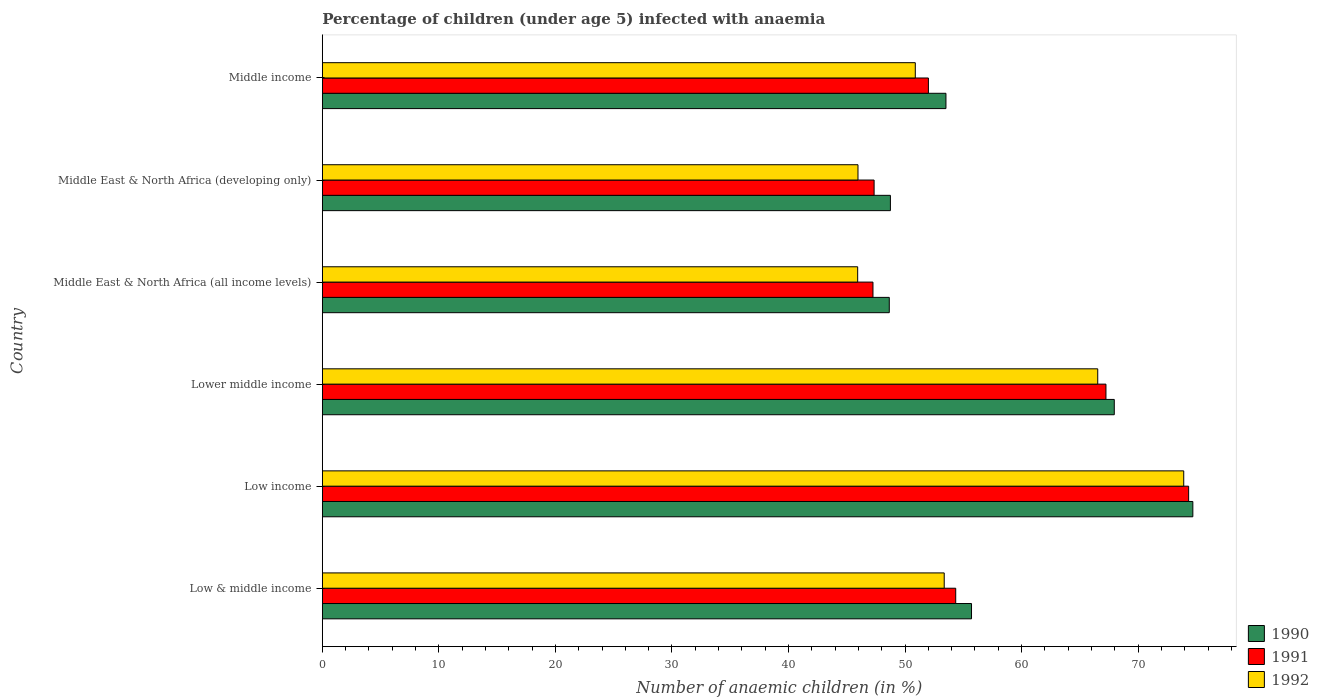Are the number of bars per tick equal to the number of legend labels?
Keep it short and to the point. Yes. Are the number of bars on each tick of the Y-axis equal?
Offer a terse response. Yes. How many bars are there on the 1st tick from the top?
Your response must be concise. 3. What is the label of the 5th group of bars from the top?
Your answer should be compact. Low income. What is the percentage of children infected with anaemia in in 1990 in Low & middle income?
Your answer should be very brief. 55.7. Across all countries, what is the maximum percentage of children infected with anaemia in in 1990?
Keep it short and to the point. 74.69. Across all countries, what is the minimum percentage of children infected with anaemia in in 1991?
Your answer should be compact. 47.25. In which country was the percentage of children infected with anaemia in in 1991 maximum?
Provide a succinct answer. Low income. In which country was the percentage of children infected with anaemia in in 1992 minimum?
Your answer should be very brief. Middle East & North Africa (all income levels). What is the total percentage of children infected with anaemia in in 1990 in the graph?
Offer a very short reply. 349.25. What is the difference between the percentage of children infected with anaemia in in 1991 in Low income and that in Lower middle income?
Provide a succinct answer. 7.1. What is the difference between the percentage of children infected with anaemia in in 1991 in Lower middle income and the percentage of children infected with anaemia in in 1992 in Low income?
Provide a short and direct response. -6.67. What is the average percentage of children infected with anaemia in in 1992 per country?
Provide a succinct answer. 56.1. What is the difference between the percentage of children infected with anaemia in in 1990 and percentage of children infected with anaemia in in 1991 in Low income?
Your response must be concise. 0.36. What is the ratio of the percentage of children infected with anaemia in in 1990 in Low & middle income to that in Low income?
Your answer should be compact. 0.75. Is the difference between the percentage of children infected with anaemia in in 1990 in Lower middle income and Middle East & North Africa (all income levels) greater than the difference between the percentage of children infected with anaemia in in 1991 in Lower middle income and Middle East & North Africa (all income levels)?
Your response must be concise. No. What is the difference between the highest and the second highest percentage of children infected with anaemia in in 1990?
Make the answer very short. 6.74. What is the difference between the highest and the lowest percentage of children infected with anaemia in in 1990?
Make the answer very short. 26.05. How many bars are there?
Give a very brief answer. 18. What is the difference between two consecutive major ticks on the X-axis?
Offer a terse response. 10. Does the graph contain grids?
Keep it short and to the point. No. Where does the legend appear in the graph?
Ensure brevity in your answer.  Bottom right. How many legend labels are there?
Offer a very short reply. 3. How are the legend labels stacked?
Your answer should be very brief. Vertical. What is the title of the graph?
Ensure brevity in your answer.  Percentage of children (under age 5) infected with anaemia. Does "1973" appear as one of the legend labels in the graph?
Make the answer very short. No. What is the label or title of the X-axis?
Your answer should be very brief. Number of anaemic children (in %). What is the Number of anaemic children (in %) of 1990 in Low & middle income?
Offer a very short reply. 55.7. What is the Number of anaemic children (in %) in 1991 in Low & middle income?
Your answer should be very brief. 54.35. What is the Number of anaemic children (in %) in 1992 in Low & middle income?
Make the answer very short. 53.36. What is the Number of anaemic children (in %) of 1990 in Low income?
Your answer should be compact. 74.69. What is the Number of anaemic children (in %) of 1991 in Low income?
Ensure brevity in your answer.  74.33. What is the Number of anaemic children (in %) of 1992 in Low income?
Ensure brevity in your answer.  73.91. What is the Number of anaemic children (in %) of 1990 in Lower middle income?
Your response must be concise. 67.95. What is the Number of anaemic children (in %) in 1991 in Lower middle income?
Keep it short and to the point. 67.24. What is the Number of anaemic children (in %) in 1992 in Lower middle income?
Your answer should be very brief. 66.53. What is the Number of anaemic children (in %) in 1990 in Middle East & North Africa (all income levels)?
Provide a succinct answer. 48.65. What is the Number of anaemic children (in %) of 1991 in Middle East & North Africa (all income levels)?
Your answer should be compact. 47.25. What is the Number of anaemic children (in %) of 1992 in Middle East & North Africa (all income levels)?
Your response must be concise. 45.93. What is the Number of anaemic children (in %) in 1990 in Middle East & North Africa (developing only)?
Offer a terse response. 48.74. What is the Number of anaemic children (in %) in 1991 in Middle East & North Africa (developing only)?
Your answer should be very brief. 47.35. What is the Number of anaemic children (in %) of 1992 in Middle East & North Africa (developing only)?
Give a very brief answer. 45.96. What is the Number of anaemic children (in %) of 1990 in Middle income?
Keep it short and to the point. 53.51. What is the Number of anaemic children (in %) of 1991 in Middle income?
Give a very brief answer. 52. What is the Number of anaemic children (in %) in 1992 in Middle income?
Keep it short and to the point. 50.88. Across all countries, what is the maximum Number of anaemic children (in %) in 1990?
Your response must be concise. 74.69. Across all countries, what is the maximum Number of anaemic children (in %) in 1991?
Offer a terse response. 74.33. Across all countries, what is the maximum Number of anaemic children (in %) in 1992?
Provide a succinct answer. 73.91. Across all countries, what is the minimum Number of anaemic children (in %) of 1990?
Your response must be concise. 48.65. Across all countries, what is the minimum Number of anaemic children (in %) in 1991?
Give a very brief answer. 47.25. Across all countries, what is the minimum Number of anaemic children (in %) of 1992?
Your answer should be compact. 45.93. What is the total Number of anaemic children (in %) of 1990 in the graph?
Offer a very short reply. 349.25. What is the total Number of anaemic children (in %) of 1991 in the graph?
Offer a very short reply. 342.52. What is the total Number of anaemic children (in %) in 1992 in the graph?
Give a very brief answer. 336.58. What is the difference between the Number of anaemic children (in %) of 1990 in Low & middle income and that in Low income?
Offer a terse response. -18.99. What is the difference between the Number of anaemic children (in %) of 1991 in Low & middle income and that in Low income?
Your response must be concise. -19.99. What is the difference between the Number of anaemic children (in %) of 1992 in Low & middle income and that in Low income?
Give a very brief answer. -20.55. What is the difference between the Number of anaemic children (in %) of 1990 in Low & middle income and that in Lower middle income?
Ensure brevity in your answer.  -12.25. What is the difference between the Number of anaemic children (in %) in 1991 in Low & middle income and that in Lower middle income?
Give a very brief answer. -12.89. What is the difference between the Number of anaemic children (in %) in 1992 in Low & middle income and that in Lower middle income?
Ensure brevity in your answer.  -13.17. What is the difference between the Number of anaemic children (in %) in 1990 in Low & middle income and that in Middle East & North Africa (all income levels)?
Offer a very short reply. 7.06. What is the difference between the Number of anaemic children (in %) in 1991 in Low & middle income and that in Middle East & North Africa (all income levels)?
Make the answer very short. 7.1. What is the difference between the Number of anaemic children (in %) of 1992 in Low & middle income and that in Middle East & North Africa (all income levels)?
Your answer should be compact. 7.43. What is the difference between the Number of anaemic children (in %) in 1990 in Low & middle income and that in Middle East & North Africa (developing only)?
Provide a short and direct response. 6.96. What is the difference between the Number of anaemic children (in %) of 1991 in Low & middle income and that in Middle East & North Africa (developing only)?
Give a very brief answer. 7. What is the difference between the Number of anaemic children (in %) of 1992 in Low & middle income and that in Middle East & North Africa (developing only)?
Your answer should be very brief. 7.4. What is the difference between the Number of anaemic children (in %) in 1990 in Low & middle income and that in Middle income?
Your answer should be compact. 2.19. What is the difference between the Number of anaemic children (in %) of 1991 in Low & middle income and that in Middle income?
Your answer should be very brief. 2.34. What is the difference between the Number of anaemic children (in %) of 1992 in Low & middle income and that in Middle income?
Make the answer very short. 2.48. What is the difference between the Number of anaemic children (in %) in 1990 in Low income and that in Lower middle income?
Make the answer very short. 6.74. What is the difference between the Number of anaemic children (in %) in 1991 in Low income and that in Lower middle income?
Offer a very short reply. 7.1. What is the difference between the Number of anaemic children (in %) in 1992 in Low income and that in Lower middle income?
Your answer should be very brief. 7.38. What is the difference between the Number of anaemic children (in %) in 1990 in Low income and that in Middle East & North Africa (all income levels)?
Your response must be concise. 26.05. What is the difference between the Number of anaemic children (in %) in 1991 in Low income and that in Middle East & North Africa (all income levels)?
Your answer should be very brief. 27.09. What is the difference between the Number of anaemic children (in %) of 1992 in Low income and that in Middle East & North Africa (all income levels)?
Offer a terse response. 27.98. What is the difference between the Number of anaemic children (in %) of 1990 in Low income and that in Middle East & North Africa (developing only)?
Your response must be concise. 25.95. What is the difference between the Number of anaemic children (in %) of 1991 in Low income and that in Middle East & North Africa (developing only)?
Provide a succinct answer. 26.99. What is the difference between the Number of anaemic children (in %) in 1992 in Low income and that in Middle East & North Africa (developing only)?
Give a very brief answer. 27.95. What is the difference between the Number of anaemic children (in %) in 1990 in Low income and that in Middle income?
Offer a very short reply. 21.18. What is the difference between the Number of anaemic children (in %) in 1991 in Low income and that in Middle income?
Your answer should be compact. 22.33. What is the difference between the Number of anaemic children (in %) of 1992 in Low income and that in Middle income?
Offer a terse response. 23.03. What is the difference between the Number of anaemic children (in %) of 1990 in Lower middle income and that in Middle East & North Africa (all income levels)?
Make the answer very short. 19.31. What is the difference between the Number of anaemic children (in %) in 1991 in Lower middle income and that in Middle East & North Africa (all income levels)?
Offer a terse response. 19.99. What is the difference between the Number of anaemic children (in %) of 1992 in Lower middle income and that in Middle East & North Africa (all income levels)?
Offer a terse response. 20.6. What is the difference between the Number of anaemic children (in %) in 1990 in Lower middle income and that in Middle East & North Africa (developing only)?
Provide a short and direct response. 19.21. What is the difference between the Number of anaemic children (in %) of 1991 in Lower middle income and that in Middle East & North Africa (developing only)?
Ensure brevity in your answer.  19.89. What is the difference between the Number of anaemic children (in %) of 1992 in Lower middle income and that in Middle East & North Africa (developing only)?
Offer a terse response. 20.57. What is the difference between the Number of anaemic children (in %) in 1990 in Lower middle income and that in Middle income?
Offer a terse response. 14.44. What is the difference between the Number of anaemic children (in %) in 1991 in Lower middle income and that in Middle income?
Ensure brevity in your answer.  15.23. What is the difference between the Number of anaemic children (in %) in 1992 in Lower middle income and that in Middle income?
Make the answer very short. 15.65. What is the difference between the Number of anaemic children (in %) in 1990 in Middle East & North Africa (all income levels) and that in Middle East & North Africa (developing only)?
Offer a terse response. -0.1. What is the difference between the Number of anaemic children (in %) of 1991 in Middle East & North Africa (all income levels) and that in Middle East & North Africa (developing only)?
Offer a terse response. -0.1. What is the difference between the Number of anaemic children (in %) in 1992 in Middle East & North Africa (all income levels) and that in Middle East & North Africa (developing only)?
Provide a succinct answer. -0.03. What is the difference between the Number of anaemic children (in %) of 1990 in Middle East & North Africa (all income levels) and that in Middle income?
Give a very brief answer. -4.86. What is the difference between the Number of anaemic children (in %) of 1991 in Middle East & North Africa (all income levels) and that in Middle income?
Provide a short and direct response. -4.76. What is the difference between the Number of anaemic children (in %) of 1992 in Middle East & North Africa (all income levels) and that in Middle income?
Keep it short and to the point. -4.94. What is the difference between the Number of anaemic children (in %) of 1990 in Middle East & North Africa (developing only) and that in Middle income?
Offer a very short reply. -4.77. What is the difference between the Number of anaemic children (in %) of 1991 in Middle East & North Africa (developing only) and that in Middle income?
Provide a succinct answer. -4.66. What is the difference between the Number of anaemic children (in %) of 1992 in Middle East & North Africa (developing only) and that in Middle income?
Keep it short and to the point. -4.92. What is the difference between the Number of anaemic children (in %) of 1990 in Low & middle income and the Number of anaemic children (in %) of 1991 in Low income?
Your answer should be compact. -18.63. What is the difference between the Number of anaemic children (in %) in 1990 in Low & middle income and the Number of anaemic children (in %) in 1992 in Low income?
Keep it short and to the point. -18.21. What is the difference between the Number of anaemic children (in %) of 1991 in Low & middle income and the Number of anaemic children (in %) of 1992 in Low income?
Offer a terse response. -19.56. What is the difference between the Number of anaemic children (in %) in 1990 in Low & middle income and the Number of anaemic children (in %) in 1991 in Lower middle income?
Your answer should be very brief. -11.54. What is the difference between the Number of anaemic children (in %) in 1990 in Low & middle income and the Number of anaemic children (in %) in 1992 in Lower middle income?
Provide a succinct answer. -10.83. What is the difference between the Number of anaemic children (in %) of 1991 in Low & middle income and the Number of anaemic children (in %) of 1992 in Lower middle income?
Provide a succinct answer. -12.19. What is the difference between the Number of anaemic children (in %) of 1990 in Low & middle income and the Number of anaemic children (in %) of 1991 in Middle East & North Africa (all income levels)?
Ensure brevity in your answer.  8.46. What is the difference between the Number of anaemic children (in %) in 1990 in Low & middle income and the Number of anaemic children (in %) in 1992 in Middle East & North Africa (all income levels)?
Your answer should be compact. 9.77. What is the difference between the Number of anaemic children (in %) in 1991 in Low & middle income and the Number of anaemic children (in %) in 1992 in Middle East & North Africa (all income levels)?
Keep it short and to the point. 8.41. What is the difference between the Number of anaemic children (in %) in 1990 in Low & middle income and the Number of anaemic children (in %) in 1991 in Middle East & North Africa (developing only)?
Offer a very short reply. 8.36. What is the difference between the Number of anaemic children (in %) in 1990 in Low & middle income and the Number of anaemic children (in %) in 1992 in Middle East & North Africa (developing only)?
Provide a succinct answer. 9.74. What is the difference between the Number of anaemic children (in %) of 1991 in Low & middle income and the Number of anaemic children (in %) of 1992 in Middle East & North Africa (developing only)?
Offer a very short reply. 8.39. What is the difference between the Number of anaemic children (in %) in 1990 in Low & middle income and the Number of anaemic children (in %) in 1991 in Middle income?
Make the answer very short. 3.7. What is the difference between the Number of anaemic children (in %) of 1990 in Low & middle income and the Number of anaemic children (in %) of 1992 in Middle income?
Offer a terse response. 4.82. What is the difference between the Number of anaemic children (in %) in 1991 in Low & middle income and the Number of anaemic children (in %) in 1992 in Middle income?
Offer a very short reply. 3.47. What is the difference between the Number of anaemic children (in %) in 1990 in Low income and the Number of anaemic children (in %) in 1991 in Lower middle income?
Give a very brief answer. 7.46. What is the difference between the Number of anaemic children (in %) in 1990 in Low income and the Number of anaemic children (in %) in 1992 in Lower middle income?
Your response must be concise. 8.16. What is the difference between the Number of anaemic children (in %) of 1991 in Low income and the Number of anaemic children (in %) of 1992 in Lower middle income?
Make the answer very short. 7.8. What is the difference between the Number of anaemic children (in %) of 1990 in Low income and the Number of anaemic children (in %) of 1991 in Middle East & North Africa (all income levels)?
Ensure brevity in your answer.  27.45. What is the difference between the Number of anaemic children (in %) in 1990 in Low income and the Number of anaemic children (in %) in 1992 in Middle East & North Africa (all income levels)?
Provide a succinct answer. 28.76. What is the difference between the Number of anaemic children (in %) of 1991 in Low income and the Number of anaemic children (in %) of 1992 in Middle East & North Africa (all income levels)?
Offer a terse response. 28.4. What is the difference between the Number of anaemic children (in %) of 1990 in Low income and the Number of anaemic children (in %) of 1991 in Middle East & North Africa (developing only)?
Keep it short and to the point. 27.35. What is the difference between the Number of anaemic children (in %) of 1990 in Low income and the Number of anaemic children (in %) of 1992 in Middle East & North Africa (developing only)?
Your answer should be compact. 28.73. What is the difference between the Number of anaemic children (in %) in 1991 in Low income and the Number of anaemic children (in %) in 1992 in Middle East & North Africa (developing only)?
Provide a short and direct response. 28.37. What is the difference between the Number of anaemic children (in %) of 1990 in Low income and the Number of anaemic children (in %) of 1991 in Middle income?
Your answer should be compact. 22.69. What is the difference between the Number of anaemic children (in %) in 1990 in Low income and the Number of anaemic children (in %) in 1992 in Middle income?
Provide a short and direct response. 23.81. What is the difference between the Number of anaemic children (in %) of 1991 in Low income and the Number of anaemic children (in %) of 1992 in Middle income?
Your answer should be compact. 23.45. What is the difference between the Number of anaemic children (in %) of 1990 in Lower middle income and the Number of anaemic children (in %) of 1991 in Middle East & North Africa (all income levels)?
Your response must be concise. 20.71. What is the difference between the Number of anaemic children (in %) of 1990 in Lower middle income and the Number of anaemic children (in %) of 1992 in Middle East & North Africa (all income levels)?
Ensure brevity in your answer.  22.02. What is the difference between the Number of anaemic children (in %) in 1991 in Lower middle income and the Number of anaemic children (in %) in 1992 in Middle East & North Africa (all income levels)?
Offer a terse response. 21.3. What is the difference between the Number of anaemic children (in %) of 1990 in Lower middle income and the Number of anaemic children (in %) of 1991 in Middle East & North Africa (developing only)?
Your response must be concise. 20.61. What is the difference between the Number of anaemic children (in %) of 1990 in Lower middle income and the Number of anaemic children (in %) of 1992 in Middle East & North Africa (developing only)?
Provide a succinct answer. 21.99. What is the difference between the Number of anaemic children (in %) in 1991 in Lower middle income and the Number of anaemic children (in %) in 1992 in Middle East & North Africa (developing only)?
Offer a terse response. 21.28. What is the difference between the Number of anaemic children (in %) of 1990 in Lower middle income and the Number of anaemic children (in %) of 1991 in Middle income?
Provide a succinct answer. 15.95. What is the difference between the Number of anaemic children (in %) in 1990 in Lower middle income and the Number of anaemic children (in %) in 1992 in Middle income?
Keep it short and to the point. 17.07. What is the difference between the Number of anaemic children (in %) of 1991 in Lower middle income and the Number of anaemic children (in %) of 1992 in Middle income?
Give a very brief answer. 16.36. What is the difference between the Number of anaemic children (in %) in 1990 in Middle East & North Africa (all income levels) and the Number of anaemic children (in %) in 1991 in Middle East & North Africa (developing only)?
Your response must be concise. 1.3. What is the difference between the Number of anaemic children (in %) in 1990 in Middle East & North Africa (all income levels) and the Number of anaemic children (in %) in 1992 in Middle East & North Africa (developing only)?
Make the answer very short. 2.69. What is the difference between the Number of anaemic children (in %) in 1991 in Middle East & North Africa (all income levels) and the Number of anaemic children (in %) in 1992 in Middle East & North Africa (developing only)?
Make the answer very short. 1.29. What is the difference between the Number of anaemic children (in %) in 1990 in Middle East & North Africa (all income levels) and the Number of anaemic children (in %) in 1991 in Middle income?
Your response must be concise. -3.36. What is the difference between the Number of anaemic children (in %) in 1990 in Middle East & North Africa (all income levels) and the Number of anaemic children (in %) in 1992 in Middle income?
Provide a short and direct response. -2.23. What is the difference between the Number of anaemic children (in %) in 1991 in Middle East & North Africa (all income levels) and the Number of anaemic children (in %) in 1992 in Middle income?
Make the answer very short. -3.63. What is the difference between the Number of anaemic children (in %) in 1990 in Middle East & North Africa (developing only) and the Number of anaemic children (in %) in 1991 in Middle income?
Provide a short and direct response. -3.26. What is the difference between the Number of anaemic children (in %) of 1990 in Middle East & North Africa (developing only) and the Number of anaemic children (in %) of 1992 in Middle income?
Your answer should be compact. -2.13. What is the difference between the Number of anaemic children (in %) in 1991 in Middle East & North Africa (developing only) and the Number of anaemic children (in %) in 1992 in Middle income?
Keep it short and to the point. -3.53. What is the average Number of anaemic children (in %) in 1990 per country?
Your answer should be very brief. 58.21. What is the average Number of anaemic children (in %) in 1991 per country?
Offer a terse response. 57.09. What is the average Number of anaemic children (in %) in 1992 per country?
Ensure brevity in your answer.  56.1. What is the difference between the Number of anaemic children (in %) of 1990 and Number of anaemic children (in %) of 1991 in Low & middle income?
Offer a terse response. 1.36. What is the difference between the Number of anaemic children (in %) of 1990 and Number of anaemic children (in %) of 1992 in Low & middle income?
Provide a succinct answer. 2.34. What is the difference between the Number of anaemic children (in %) of 1991 and Number of anaemic children (in %) of 1992 in Low & middle income?
Give a very brief answer. 0.99. What is the difference between the Number of anaemic children (in %) of 1990 and Number of anaemic children (in %) of 1991 in Low income?
Your answer should be very brief. 0.36. What is the difference between the Number of anaemic children (in %) of 1990 and Number of anaemic children (in %) of 1992 in Low income?
Offer a very short reply. 0.78. What is the difference between the Number of anaemic children (in %) in 1991 and Number of anaemic children (in %) in 1992 in Low income?
Ensure brevity in your answer.  0.42. What is the difference between the Number of anaemic children (in %) of 1990 and Number of anaemic children (in %) of 1991 in Lower middle income?
Keep it short and to the point. 0.71. What is the difference between the Number of anaemic children (in %) of 1990 and Number of anaemic children (in %) of 1992 in Lower middle income?
Make the answer very short. 1.42. What is the difference between the Number of anaemic children (in %) in 1991 and Number of anaemic children (in %) in 1992 in Lower middle income?
Keep it short and to the point. 0.7. What is the difference between the Number of anaemic children (in %) in 1990 and Number of anaemic children (in %) in 1991 in Middle East & North Africa (all income levels)?
Offer a terse response. 1.4. What is the difference between the Number of anaemic children (in %) in 1990 and Number of anaemic children (in %) in 1992 in Middle East & North Africa (all income levels)?
Provide a short and direct response. 2.71. What is the difference between the Number of anaemic children (in %) of 1991 and Number of anaemic children (in %) of 1992 in Middle East & North Africa (all income levels)?
Offer a very short reply. 1.31. What is the difference between the Number of anaemic children (in %) in 1990 and Number of anaemic children (in %) in 1991 in Middle East & North Africa (developing only)?
Your response must be concise. 1.4. What is the difference between the Number of anaemic children (in %) in 1990 and Number of anaemic children (in %) in 1992 in Middle East & North Africa (developing only)?
Keep it short and to the point. 2.78. What is the difference between the Number of anaemic children (in %) of 1991 and Number of anaemic children (in %) of 1992 in Middle East & North Africa (developing only)?
Offer a terse response. 1.38. What is the difference between the Number of anaemic children (in %) in 1990 and Number of anaemic children (in %) in 1991 in Middle income?
Ensure brevity in your answer.  1.51. What is the difference between the Number of anaemic children (in %) of 1990 and Number of anaemic children (in %) of 1992 in Middle income?
Your response must be concise. 2.63. What is the difference between the Number of anaemic children (in %) of 1991 and Number of anaemic children (in %) of 1992 in Middle income?
Give a very brief answer. 1.13. What is the ratio of the Number of anaemic children (in %) of 1990 in Low & middle income to that in Low income?
Make the answer very short. 0.75. What is the ratio of the Number of anaemic children (in %) of 1991 in Low & middle income to that in Low income?
Provide a succinct answer. 0.73. What is the ratio of the Number of anaemic children (in %) of 1992 in Low & middle income to that in Low income?
Your response must be concise. 0.72. What is the ratio of the Number of anaemic children (in %) in 1990 in Low & middle income to that in Lower middle income?
Offer a terse response. 0.82. What is the ratio of the Number of anaemic children (in %) in 1991 in Low & middle income to that in Lower middle income?
Keep it short and to the point. 0.81. What is the ratio of the Number of anaemic children (in %) of 1992 in Low & middle income to that in Lower middle income?
Keep it short and to the point. 0.8. What is the ratio of the Number of anaemic children (in %) of 1990 in Low & middle income to that in Middle East & North Africa (all income levels)?
Your response must be concise. 1.15. What is the ratio of the Number of anaemic children (in %) in 1991 in Low & middle income to that in Middle East & North Africa (all income levels)?
Give a very brief answer. 1.15. What is the ratio of the Number of anaemic children (in %) in 1992 in Low & middle income to that in Middle East & North Africa (all income levels)?
Keep it short and to the point. 1.16. What is the ratio of the Number of anaemic children (in %) of 1990 in Low & middle income to that in Middle East & North Africa (developing only)?
Make the answer very short. 1.14. What is the ratio of the Number of anaemic children (in %) of 1991 in Low & middle income to that in Middle East & North Africa (developing only)?
Make the answer very short. 1.15. What is the ratio of the Number of anaemic children (in %) of 1992 in Low & middle income to that in Middle East & North Africa (developing only)?
Your answer should be compact. 1.16. What is the ratio of the Number of anaemic children (in %) of 1990 in Low & middle income to that in Middle income?
Offer a terse response. 1.04. What is the ratio of the Number of anaemic children (in %) of 1991 in Low & middle income to that in Middle income?
Ensure brevity in your answer.  1.05. What is the ratio of the Number of anaemic children (in %) in 1992 in Low & middle income to that in Middle income?
Ensure brevity in your answer.  1.05. What is the ratio of the Number of anaemic children (in %) in 1990 in Low income to that in Lower middle income?
Keep it short and to the point. 1.1. What is the ratio of the Number of anaemic children (in %) in 1991 in Low income to that in Lower middle income?
Make the answer very short. 1.11. What is the ratio of the Number of anaemic children (in %) of 1992 in Low income to that in Lower middle income?
Give a very brief answer. 1.11. What is the ratio of the Number of anaemic children (in %) of 1990 in Low income to that in Middle East & North Africa (all income levels)?
Make the answer very short. 1.54. What is the ratio of the Number of anaemic children (in %) of 1991 in Low income to that in Middle East & North Africa (all income levels)?
Keep it short and to the point. 1.57. What is the ratio of the Number of anaemic children (in %) of 1992 in Low income to that in Middle East & North Africa (all income levels)?
Your answer should be very brief. 1.61. What is the ratio of the Number of anaemic children (in %) of 1990 in Low income to that in Middle East & North Africa (developing only)?
Offer a terse response. 1.53. What is the ratio of the Number of anaemic children (in %) of 1991 in Low income to that in Middle East & North Africa (developing only)?
Your answer should be compact. 1.57. What is the ratio of the Number of anaemic children (in %) of 1992 in Low income to that in Middle East & North Africa (developing only)?
Offer a very short reply. 1.61. What is the ratio of the Number of anaemic children (in %) in 1990 in Low income to that in Middle income?
Make the answer very short. 1.4. What is the ratio of the Number of anaemic children (in %) of 1991 in Low income to that in Middle income?
Provide a succinct answer. 1.43. What is the ratio of the Number of anaemic children (in %) of 1992 in Low income to that in Middle income?
Your answer should be very brief. 1.45. What is the ratio of the Number of anaemic children (in %) of 1990 in Lower middle income to that in Middle East & North Africa (all income levels)?
Provide a short and direct response. 1.4. What is the ratio of the Number of anaemic children (in %) in 1991 in Lower middle income to that in Middle East & North Africa (all income levels)?
Ensure brevity in your answer.  1.42. What is the ratio of the Number of anaemic children (in %) of 1992 in Lower middle income to that in Middle East & North Africa (all income levels)?
Keep it short and to the point. 1.45. What is the ratio of the Number of anaemic children (in %) of 1990 in Lower middle income to that in Middle East & North Africa (developing only)?
Make the answer very short. 1.39. What is the ratio of the Number of anaemic children (in %) in 1991 in Lower middle income to that in Middle East & North Africa (developing only)?
Offer a terse response. 1.42. What is the ratio of the Number of anaemic children (in %) of 1992 in Lower middle income to that in Middle East & North Africa (developing only)?
Make the answer very short. 1.45. What is the ratio of the Number of anaemic children (in %) in 1990 in Lower middle income to that in Middle income?
Provide a short and direct response. 1.27. What is the ratio of the Number of anaemic children (in %) of 1991 in Lower middle income to that in Middle income?
Give a very brief answer. 1.29. What is the ratio of the Number of anaemic children (in %) of 1992 in Lower middle income to that in Middle income?
Ensure brevity in your answer.  1.31. What is the ratio of the Number of anaemic children (in %) of 1991 in Middle East & North Africa (all income levels) to that in Middle East & North Africa (developing only)?
Your answer should be very brief. 1. What is the ratio of the Number of anaemic children (in %) in 1992 in Middle East & North Africa (all income levels) to that in Middle East & North Africa (developing only)?
Your response must be concise. 1. What is the ratio of the Number of anaemic children (in %) of 1991 in Middle East & North Africa (all income levels) to that in Middle income?
Your answer should be very brief. 0.91. What is the ratio of the Number of anaemic children (in %) in 1992 in Middle East & North Africa (all income levels) to that in Middle income?
Your answer should be compact. 0.9. What is the ratio of the Number of anaemic children (in %) of 1990 in Middle East & North Africa (developing only) to that in Middle income?
Offer a very short reply. 0.91. What is the ratio of the Number of anaemic children (in %) of 1991 in Middle East & North Africa (developing only) to that in Middle income?
Your answer should be very brief. 0.91. What is the ratio of the Number of anaemic children (in %) in 1992 in Middle East & North Africa (developing only) to that in Middle income?
Keep it short and to the point. 0.9. What is the difference between the highest and the second highest Number of anaemic children (in %) of 1990?
Your response must be concise. 6.74. What is the difference between the highest and the second highest Number of anaemic children (in %) in 1991?
Offer a very short reply. 7.1. What is the difference between the highest and the second highest Number of anaemic children (in %) in 1992?
Ensure brevity in your answer.  7.38. What is the difference between the highest and the lowest Number of anaemic children (in %) in 1990?
Offer a very short reply. 26.05. What is the difference between the highest and the lowest Number of anaemic children (in %) of 1991?
Keep it short and to the point. 27.09. What is the difference between the highest and the lowest Number of anaemic children (in %) in 1992?
Keep it short and to the point. 27.98. 